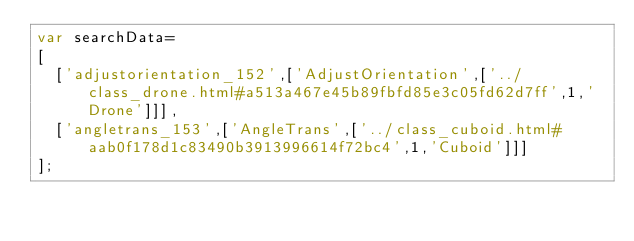Convert code to text. <code><loc_0><loc_0><loc_500><loc_500><_JavaScript_>var searchData=
[
  ['adjustorientation_152',['AdjustOrientation',['../class_drone.html#a513a467e45b89fbfd85e3c05fd62d7ff',1,'Drone']]],
  ['angletrans_153',['AngleTrans',['../class_cuboid.html#aab0f178d1c83490b3913996614f72bc4',1,'Cuboid']]]
];
</code> 